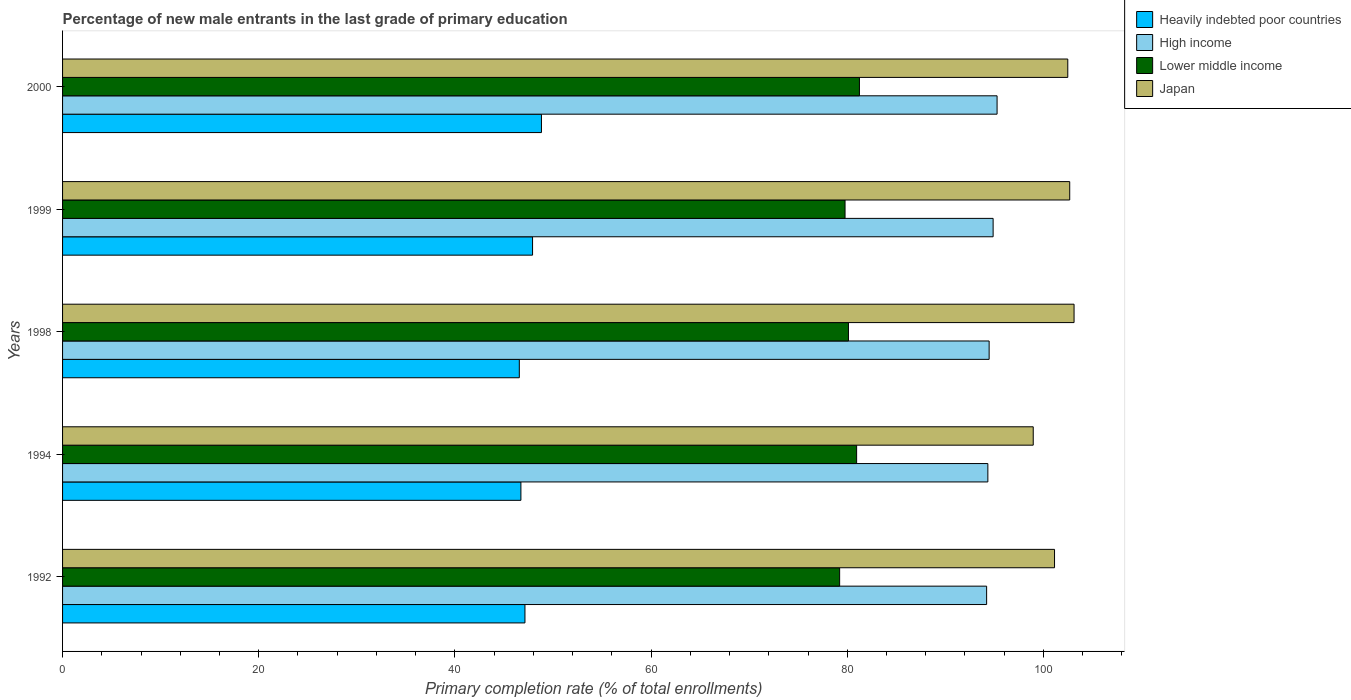How many groups of bars are there?
Offer a very short reply. 5. Are the number of bars per tick equal to the number of legend labels?
Your answer should be compact. Yes. Are the number of bars on each tick of the Y-axis equal?
Your answer should be compact. Yes. How many bars are there on the 3rd tick from the top?
Give a very brief answer. 4. What is the label of the 4th group of bars from the top?
Ensure brevity in your answer.  1994. What is the percentage of new male entrants in Lower middle income in 1998?
Your answer should be very brief. 80.12. Across all years, what is the maximum percentage of new male entrants in Japan?
Your answer should be compact. 103.12. Across all years, what is the minimum percentage of new male entrants in Heavily indebted poor countries?
Your answer should be very brief. 46.57. In which year was the percentage of new male entrants in High income minimum?
Ensure brevity in your answer.  1992. What is the total percentage of new male entrants in Lower middle income in the graph?
Keep it short and to the point. 401.32. What is the difference between the percentage of new male entrants in Japan in 1998 and that in 1999?
Provide a short and direct response. 0.44. What is the difference between the percentage of new male entrants in Lower middle income in 1994 and the percentage of new male entrants in Heavily indebted poor countries in 2000?
Provide a short and direct response. 32.13. What is the average percentage of new male entrants in Heavily indebted poor countries per year?
Keep it short and to the point. 47.43. In the year 1994, what is the difference between the percentage of new male entrants in Lower middle income and percentage of new male entrants in High income?
Make the answer very short. -13.38. What is the ratio of the percentage of new male entrants in High income in 1992 to that in 1999?
Give a very brief answer. 0.99. Is the percentage of new male entrants in Japan in 1994 less than that in 1999?
Offer a very short reply. Yes. Is the difference between the percentage of new male entrants in Lower middle income in 1992 and 1999 greater than the difference between the percentage of new male entrants in High income in 1992 and 1999?
Give a very brief answer. Yes. What is the difference between the highest and the second highest percentage of new male entrants in High income?
Your answer should be very brief. 0.4. What is the difference between the highest and the lowest percentage of new male entrants in Heavily indebted poor countries?
Give a very brief answer. 2.26. In how many years, is the percentage of new male entrants in High income greater than the average percentage of new male entrants in High income taken over all years?
Provide a succinct answer. 2. Is the sum of the percentage of new male entrants in Lower middle income in 1992 and 1998 greater than the maximum percentage of new male entrants in Heavily indebted poor countries across all years?
Offer a terse response. Yes. What does the 2nd bar from the bottom in 1998 represents?
Offer a terse response. High income. Is it the case that in every year, the sum of the percentage of new male entrants in Heavily indebted poor countries and percentage of new male entrants in Japan is greater than the percentage of new male entrants in Lower middle income?
Your answer should be very brief. Yes. Are all the bars in the graph horizontal?
Make the answer very short. Yes. What is the difference between two consecutive major ticks on the X-axis?
Offer a very short reply. 20. What is the title of the graph?
Give a very brief answer. Percentage of new male entrants in the last grade of primary education. Does "Belgium" appear as one of the legend labels in the graph?
Your response must be concise. No. What is the label or title of the X-axis?
Your response must be concise. Primary completion rate (% of total enrollments). What is the Primary completion rate (% of total enrollments) in Heavily indebted poor countries in 1992?
Offer a very short reply. 47.14. What is the Primary completion rate (% of total enrollments) of High income in 1992?
Offer a very short reply. 94.21. What is the Primary completion rate (% of total enrollments) in Lower middle income in 1992?
Your response must be concise. 79.22. What is the Primary completion rate (% of total enrollments) of Japan in 1992?
Your answer should be very brief. 101.13. What is the Primary completion rate (% of total enrollments) in Heavily indebted poor countries in 1994?
Your response must be concise. 46.73. What is the Primary completion rate (% of total enrollments) of High income in 1994?
Keep it short and to the point. 94.33. What is the Primary completion rate (% of total enrollments) of Lower middle income in 1994?
Your answer should be very brief. 80.96. What is the Primary completion rate (% of total enrollments) of Japan in 1994?
Give a very brief answer. 98.96. What is the Primary completion rate (% of total enrollments) in Heavily indebted poor countries in 1998?
Keep it short and to the point. 46.57. What is the Primary completion rate (% of total enrollments) of High income in 1998?
Give a very brief answer. 94.47. What is the Primary completion rate (% of total enrollments) in Lower middle income in 1998?
Make the answer very short. 80.12. What is the Primary completion rate (% of total enrollments) of Japan in 1998?
Your answer should be very brief. 103.12. What is the Primary completion rate (% of total enrollments) in Heavily indebted poor countries in 1999?
Make the answer very short. 47.92. What is the Primary completion rate (% of total enrollments) in High income in 1999?
Provide a short and direct response. 94.87. What is the Primary completion rate (% of total enrollments) of Lower middle income in 1999?
Ensure brevity in your answer.  79.77. What is the Primary completion rate (% of total enrollments) of Japan in 1999?
Your response must be concise. 102.68. What is the Primary completion rate (% of total enrollments) in Heavily indebted poor countries in 2000?
Offer a very short reply. 48.82. What is the Primary completion rate (% of total enrollments) of High income in 2000?
Offer a terse response. 95.27. What is the Primary completion rate (% of total enrollments) in Lower middle income in 2000?
Keep it short and to the point. 81.24. What is the Primary completion rate (% of total enrollments) in Japan in 2000?
Your answer should be very brief. 102.48. Across all years, what is the maximum Primary completion rate (% of total enrollments) of Heavily indebted poor countries?
Your answer should be very brief. 48.82. Across all years, what is the maximum Primary completion rate (% of total enrollments) of High income?
Your answer should be very brief. 95.27. Across all years, what is the maximum Primary completion rate (% of total enrollments) of Lower middle income?
Offer a very short reply. 81.24. Across all years, what is the maximum Primary completion rate (% of total enrollments) of Japan?
Ensure brevity in your answer.  103.12. Across all years, what is the minimum Primary completion rate (% of total enrollments) in Heavily indebted poor countries?
Your response must be concise. 46.57. Across all years, what is the minimum Primary completion rate (% of total enrollments) in High income?
Give a very brief answer. 94.21. Across all years, what is the minimum Primary completion rate (% of total enrollments) of Lower middle income?
Keep it short and to the point. 79.22. Across all years, what is the minimum Primary completion rate (% of total enrollments) of Japan?
Ensure brevity in your answer.  98.96. What is the total Primary completion rate (% of total enrollments) of Heavily indebted poor countries in the graph?
Provide a succinct answer. 237.17. What is the total Primary completion rate (% of total enrollments) of High income in the graph?
Keep it short and to the point. 473.15. What is the total Primary completion rate (% of total enrollments) of Lower middle income in the graph?
Give a very brief answer. 401.32. What is the total Primary completion rate (% of total enrollments) of Japan in the graph?
Give a very brief answer. 508.38. What is the difference between the Primary completion rate (% of total enrollments) of Heavily indebted poor countries in 1992 and that in 1994?
Give a very brief answer. 0.41. What is the difference between the Primary completion rate (% of total enrollments) in High income in 1992 and that in 1994?
Provide a succinct answer. -0.13. What is the difference between the Primary completion rate (% of total enrollments) of Lower middle income in 1992 and that in 1994?
Give a very brief answer. -1.73. What is the difference between the Primary completion rate (% of total enrollments) of Japan in 1992 and that in 1994?
Provide a short and direct response. 2.17. What is the difference between the Primary completion rate (% of total enrollments) in Heavily indebted poor countries in 1992 and that in 1998?
Offer a terse response. 0.58. What is the difference between the Primary completion rate (% of total enrollments) in High income in 1992 and that in 1998?
Keep it short and to the point. -0.26. What is the difference between the Primary completion rate (% of total enrollments) in Lower middle income in 1992 and that in 1998?
Your answer should be very brief. -0.9. What is the difference between the Primary completion rate (% of total enrollments) in Japan in 1992 and that in 1998?
Your answer should be compact. -1.99. What is the difference between the Primary completion rate (% of total enrollments) in Heavily indebted poor countries in 1992 and that in 1999?
Make the answer very short. -0.78. What is the difference between the Primary completion rate (% of total enrollments) of High income in 1992 and that in 1999?
Give a very brief answer. -0.66. What is the difference between the Primary completion rate (% of total enrollments) of Lower middle income in 1992 and that in 1999?
Offer a terse response. -0.55. What is the difference between the Primary completion rate (% of total enrollments) of Japan in 1992 and that in 1999?
Keep it short and to the point. -1.55. What is the difference between the Primary completion rate (% of total enrollments) of Heavily indebted poor countries in 1992 and that in 2000?
Ensure brevity in your answer.  -1.68. What is the difference between the Primary completion rate (% of total enrollments) in High income in 1992 and that in 2000?
Offer a very short reply. -1.07. What is the difference between the Primary completion rate (% of total enrollments) of Lower middle income in 1992 and that in 2000?
Ensure brevity in your answer.  -2.02. What is the difference between the Primary completion rate (% of total enrollments) of Japan in 1992 and that in 2000?
Keep it short and to the point. -1.35. What is the difference between the Primary completion rate (% of total enrollments) of Heavily indebted poor countries in 1994 and that in 1998?
Offer a very short reply. 0.16. What is the difference between the Primary completion rate (% of total enrollments) in High income in 1994 and that in 1998?
Make the answer very short. -0.13. What is the difference between the Primary completion rate (% of total enrollments) in Lower middle income in 1994 and that in 1998?
Your answer should be compact. 0.83. What is the difference between the Primary completion rate (% of total enrollments) in Japan in 1994 and that in 1998?
Provide a short and direct response. -4.16. What is the difference between the Primary completion rate (% of total enrollments) in Heavily indebted poor countries in 1994 and that in 1999?
Keep it short and to the point. -1.19. What is the difference between the Primary completion rate (% of total enrollments) of High income in 1994 and that in 1999?
Give a very brief answer. -0.54. What is the difference between the Primary completion rate (% of total enrollments) of Lower middle income in 1994 and that in 1999?
Your answer should be very brief. 1.18. What is the difference between the Primary completion rate (% of total enrollments) of Japan in 1994 and that in 1999?
Your answer should be very brief. -3.72. What is the difference between the Primary completion rate (% of total enrollments) in Heavily indebted poor countries in 1994 and that in 2000?
Keep it short and to the point. -2.09. What is the difference between the Primary completion rate (% of total enrollments) in High income in 1994 and that in 2000?
Make the answer very short. -0.94. What is the difference between the Primary completion rate (% of total enrollments) of Lower middle income in 1994 and that in 2000?
Provide a succinct answer. -0.29. What is the difference between the Primary completion rate (% of total enrollments) of Japan in 1994 and that in 2000?
Provide a succinct answer. -3.52. What is the difference between the Primary completion rate (% of total enrollments) in Heavily indebted poor countries in 1998 and that in 1999?
Provide a short and direct response. -1.35. What is the difference between the Primary completion rate (% of total enrollments) of High income in 1998 and that in 1999?
Provide a succinct answer. -0.41. What is the difference between the Primary completion rate (% of total enrollments) of Lower middle income in 1998 and that in 1999?
Provide a succinct answer. 0.35. What is the difference between the Primary completion rate (% of total enrollments) in Japan in 1998 and that in 1999?
Provide a succinct answer. 0.44. What is the difference between the Primary completion rate (% of total enrollments) of Heavily indebted poor countries in 1998 and that in 2000?
Ensure brevity in your answer.  -2.26. What is the difference between the Primary completion rate (% of total enrollments) in High income in 1998 and that in 2000?
Make the answer very short. -0.81. What is the difference between the Primary completion rate (% of total enrollments) in Lower middle income in 1998 and that in 2000?
Provide a succinct answer. -1.12. What is the difference between the Primary completion rate (% of total enrollments) of Japan in 1998 and that in 2000?
Your answer should be very brief. 0.64. What is the difference between the Primary completion rate (% of total enrollments) of Heavily indebted poor countries in 1999 and that in 2000?
Offer a terse response. -0.91. What is the difference between the Primary completion rate (% of total enrollments) in High income in 1999 and that in 2000?
Your answer should be very brief. -0.4. What is the difference between the Primary completion rate (% of total enrollments) of Lower middle income in 1999 and that in 2000?
Offer a very short reply. -1.47. What is the difference between the Primary completion rate (% of total enrollments) of Japan in 1999 and that in 2000?
Your response must be concise. 0.2. What is the difference between the Primary completion rate (% of total enrollments) of Heavily indebted poor countries in 1992 and the Primary completion rate (% of total enrollments) of High income in 1994?
Give a very brief answer. -47.19. What is the difference between the Primary completion rate (% of total enrollments) in Heavily indebted poor countries in 1992 and the Primary completion rate (% of total enrollments) in Lower middle income in 1994?
Your response must be concise. -33.81. What is the difference between the Primary completion rate (% of total enrollments) of Heavily indebted poor countries in 1992 and the Primary completion rate (% of total enrollments) of Japan in 1994?
Provide a succinct answer. -51.82. What is the difference between the Primary completion rate (% of total enrollments) of High income in 1992 and the Primary completion rate (% of total enrollments) of Lower middle income in 1994?
Offer a very short reply. 13.25. What is the difference between the Primary completion rate (% of total enrollments) in High income in 1992 and the Primary completion rate (% of total enrollments) in Japan in 1994?
Your response must be concise. -4.75. What is the difference between the Primary completion rate (% of total enrollments) of Lower middle income in 1992 and the Primary completion rate (% of total enrollments) of Japan in 1994?
Ensure brevity in your answer.  -19.74. What is the difference between the Primary completion rate (% of total enrollments) in Heavily indebted poor countries in 1992 and the Primary completion rate (% of total enrollments) in High income in 1998?
Make the answer very short. -47.32. What is the difference between the Primary completion rate (% of total enrollments) in Heavily indebted poor countries in 1992 and the Primary completion rate (% of total enrollments) in Lower middle income in 1998?
Provide a succinct answer. -32.98. What is the difference between the Primary completion rate (% of total enrollments) in Heavily indebted poor countries in 1992 and the Primary completion rate (% of total enrollments) in Japan in 1998?
Offer a very short reply. -55.98. What is the difference between the Primary completion rate (% of total enrollments) of High income in 1992 and the Primary completion rate (% of total enrollments) of Lower middle income in 1998?
Offer a terse response. 14.09. What is the difference between the Primary completion rate (% of total enrollments) of High income in 1992 and the Primary completion rate (% of total enrollments) of Japan in 1998?
Make the answer very short. -8.91. What is the difference between the Primary completion rate (% of total enrollments) in Lower middle income in 1992 and the Primary completion rate (% of total enrollments) in Japan in 1998?
Give a very brief answer. -23.9. What is the difference between the Primary completion rate (% of total enrollments) in Heavily indebted poor countries in 1992 and the Primary completion rate (% of total enrollments) in High income in 1999?
Give a very brief answer. -47.73. What is the difference between the Primary completion rate (% of total enrollments) in Heavily indebted poor countries in 1992 and the Primary completion rate (% of total enrollments) in Lower middle income in 1999?
Your answer should be compact. -32.63. What is the difference between the Primary completion rate (% of total enrollments) in Heavily indebted poor countries in 1992 and the Primary completion rate (% of total enrollments) in Japan in 1999?
Your answer should be compact. -55.54. What is the difference between the Primary completion rate (% of total enrollments) in High income in 1992 and the Primary completion rate (% of total enrollments) in Lower middle income in 1999?
Offer a very short reply. 14.43. What is the difference between the Primary completion rate (% of total enrollments) of High income in 1992 and the Primary completion rate (% of total enrollments) of Japan in 1999?
Your answer should be compact. -8.47. What is the difference between the Primary completion rate (% of total enrollments) of Lower middle income in 1992 and the Primary completion rate (% of total enrollments) of Japan in 1999?
Give a very brief answer. -23.46. What is the difference between the Primary completion rate (% of total enrollments) in Heavily indebted poor countries in 1992 and the Primary completion rate (% of total enrollments) in High income in 2000?
Your response must be concise. -48.13. What is the difference between the Primary completion rate (% of total enrollments) in Heavily indebted poor countries in 1992 and the Primary completion rate (% of total enrollments) in Lower middle income in 2000?
Offer a terse response. -34.1. What is the difference between the Primary completion rate (% of total enrollments) in Heavily indebted poor countries in 1992 and the Primary completion rate (% of total enrollments) in Japan in 2000?
Provide a succinct answer. -55.34. What is the difference between the Primary completion rate (% of total enrollments) in High income in 1992 and the Primary completion rate (% of total enrollments) in Lower middle income in 2000?
Provide a short and direct response. 12.97. What is the difference between the Primary completion rate (% of total enrollments) of High income in 1992 and the Primary completion rate (% of total enrollments) of Japan in 2000?
Offer a terse response. -8.27. What is the difference between the Primary completion rate (% of total enrollments) of Lower middle income in 1992 and the Primary completion rate (% of total enrollments) of Japan in 2000?
Your answer should be compact. -23.26. What is the difference between the Primary completion rate (% of total enrollments) in Heavily indebted poor countries in 1994 and the Primary completion rate (% of total enrollments) in High income in 1998?
Make the answer very short. -47.74. What is the difference between the Primary completion rate (% of total enrollments) in Heavily indebted poor countries in 1994 and the Primary completion rate (% of total enrollments) in Lower middle income in 1998?
Make the answer very short. -33.39. What is the difference between the Primary completion rate (% of total enrollments) of Heavily indebted poor countries in 1994 and the Primary completion rate (% of total enrollments) of Japan in 1998?
Keep it short and to the point. -56.39. What is the difference between the Primary completion rate (% of total enrollments) of High income in 1994 and the Primary completion rate (% of total enrollments) of Lower middle income in 1998?
Ensure brevity in your answer.  14.21. What is the difference between the Primary completion rate (% of total enrollments) of High income in 1994 and the Primary completion rate (% of total enrollments) of Japan in 1998?
Your answer should be compact. -8.79. What is the difference between the Primary completion rate (% of total enrollments) of Lower middle income in 1994 and the Primary completion rate (% of total enrollments) of Japan in 1998?
Keep it short and to the point. -22.17. What is the difference between the Primary completion rate (% of total enrollments) of Heavily indebted poor countries in 1994 and the Primary completion rate (% of total enrollments) of High income in 1999?
Ensure brevity in your answer.  -48.14. What is the difference between the Primary completion rate (% of total enrollments) in Heavily indebted poor countries in 1994 and the Primary completion rate (% of total enrollments) in Lower middle income in 1999?
Make the answer very short. -33.05. What is the difference between the Primary completion rate (% of total enrollments) of Heavily indebted poor countries in 1994 and the Primary completion rate (% of total enrollments) of Japan in 1999?
Your response must be concise. -55.95. What is the difference between the Primary completion rate (% of total enrollments) of High income in 1994 and the Primary completion rate (% of total enrollments) of Lower middle income in 1999?
Make the answer very short. 14.56. What is the difference between the Primary completion rate (% of total enrollments) of High income in 1994 and the Primary completion rate (% of total enrollments) of Japan in 1999?
Your response must be concise. -8.35. What is the difference between the Primary completion rate (% of total enrollments) in Lower middle income in 1994 and the Primary completion rate (% of total enrollments) in Japan in 1999?
Give a very brief answer. -21.72. What is the difference between the Primary completion rate (% of total enrollments) in Heavily indebted poor countries in 1994 and the Primary completion rate (% of total enrollments) in High income in 2000?
Your response must be concise. -48.55. What is the difference between the Primary completion rate (% of total enrollments) of Heavily indebted poor countries in 1994 and the Primary completion rate (% of total enrollments) of Lower middle income in 2000?
Keep it short and to the point. -34.51. What is the difference between the Primary completion rate (% of total enrollments) of Heavily indebted poor countries in 1994 and the Primary completion rate (% of total enrollments) of Japan in 2000?
Ensure brevity in your answer.  -55.75. What is the difference between the Primary completion rate (% of total enrollments) in High income in 1994 and the Primary completion rate (% of total enrollments) in Lower middle income in 2000?
Provide a short and direct response. 13.09. What is the difference between the Primary completion rate (% of total enrollments) in High income in 1994 and the Primary completion rate (% of total enrollments) in Japan in 2000?
Offer a very short reply. -8.15. What is the difference between the Primary completion rate (% of total enrollments) of Lower middle income in 1994 and the Primary completion rate (% of total enrollments) of Japan in 2000?
Ensure brevity in your answer.  -21.53. What is the difference between the Primary completion rate (% of total enrollments) in Heavily indebted poor countries in 1998 and the Primary completion rate (% of total enrollments) in High income in 1999?
Keep it short and to the point. -48.31. What is the difference between the Primary completion rate (% of total enrollments) of Heavily indebted poor countries in 1998 and the Primary completion rate (% of total enrollments) of Lower middle income in 1999?
Your answer should be compact. -33.21. What is the difference between the Primary completion rate (% of total enrollments) of Heavily indebted poor countries in 1998 and the Primary completion rate (% of total enrollments) of Japan in 1999?
Give a very brief answer. -56.11. What is the difference between the Primary completion rate (% of total enrollments) of High income in 1998 and the Primary completion rate (% of total enrollments) of Lower middle income in 1999?
Your answer should be very brief. 14.69. What is the difference between the Primary completion rate (% of total enrollments) of High income in 1998 and the Primary completion rate (% of total enrollments) of Japan in 1999?
Ensure brevity in your answer.  -8.21. What is the difference between the Primary completion rate (% of total enrollments) in Lower middle income in 1998 and the Primary completion rate (% of total enrollments) in Japan in 1999?
Your response must be concise. -22.56. What is the difference between the Primary completion rate (% of total enrollments) in Heavily indebted poor countries in 1998 and the Primary completion rate (% of total enrollments) in High income in 2000?
Your answer should be compact. -48.71. What is the difference between the Primary completion rate (% of total enrollments) in Heavily indebted poor countries in 1998 and the Primary completion rate (% of total enrollments) in Lower middle income in 2000?
Make the answer very short. -34.68. What is the difference between the Primary completion rate (% of total enrollments) in Heavily indebted poor countries in 1998 and the Primary completion rate (% of total enrollments) in Japan in 2000?
Your response must be concise. -55.92. What is the difference between the Primary completion rate (% of total enrollments) in High income in 1998 and the Primary completion rate (% of total enrollments) in Lower middle income in 2000?
Make the answer very short. 13.22. What is the difference between the Primary completion rate (% of total enrollments) of High income in 1998 and the Primary completion rate (% of total enrollments) of Japan in 2000?
Make the answer very short. -8.02. What is the difference between the Primary completion rate (% of total enrollments) in Lower middle income in 1998 and the Primary completion rate (% of total enrollments) in Japan in 2000?
Keep it short and to the point. -22.36. What is the difference between the Primary completion rate (% of total enrollments) in Heavily indebted poor countries in 1999 and the Primary completion rate (% of total enrollments) in High income in 2000?
Your answer should be compact. -47.36. What is the difference between the Primary completion rate (% of total enrollments) of Heavily indebted poor countries in 1999 and the Primary completion rate (% of total enrollments) of Lower middle income in 2000?
Your answer should be very brief. -33.33. What is the difference between the Primary completion rate (% of total enrollments) of Heavily indebted poor countries in 1999 and the Primary completion rate (% of total enrollments) of Japan in 2000?
Your response must be concise. -54.57. What is the difference between the Primary completion rate (% of total enrollments) of High income in 1999 and the Primary completion rate (% of total enrollments) of Lower middle income in 2000?
Offer a terse response. 13.63. What is the difference between the Primary completion rate (% of total enrollments) of High income in 1999 and the Primary completion rate (% of total enrollments) of Japan in 2000?
Give a very brief answer. -7.61. What is the difference between the Primary completion rate (% of total enrollments) in Lower middle income in 1999 and the Primary completion rate (% of total enrollments) in Japan in 2000?
Your answer should be compact. -22.71. What is the average Primary completion rate (% of total enrollments) of Heavily indebted poor countries per year?
Offer a very short reply. 47.44. What is the average Primary completion rate (% of total enrollments) in High income per year?
Make the answer very short. 94.63. What is the average Primary completion rate (% of total enrollments) in Lower middle income per year?
Give a very brief answer. 80.26. What is the average Primary completion rate (% of total enrollments) in Japan per year?
Offer a very short reply. 101.68. In the year 1992, what is the difference between the Primary completion rate (% of total enrollments) in Heavily indebted poor countries and Primary completion rate (% of total enrollments) in High income?
Your answer should be very brief. -47.07. In the year 1992, what is the difference between the Primary completion rate (% of total enrollments) in Heavily indebted poor countries and Primary completion rate (% of total enrollments) in Lower middle income?
Your answer should be very brief. -32.08. In the year 1992, what is the difference between the Primary completion rate (% of total enrollments) of Heavily indebted poor countries and Primary completion rate (% of total enrollments) of Japan?
Offer a terse response. -53.99. In the year 1992, what is the difference between the Primary completion rate (% of total enrollments) in High income and Primary completion rate (% of total enrollments) in Lower middle income?
Provide a short and direct response. 14.98. In the year 1992, what is the difference between the Primary completion rate (% of total enrollments) of High income and Primary completion rate (% of total enrollments) of Japan?
Your answer should be compact. -6.92. In the year 1992, what is the difference between the Primary completion rate (% of total enrollments) in Lower middle income and Primary completion rate (% of total enrollments) in Japan?
Ensure brevity in your answer.  -21.91. In the year 1994, what is the difference between the Primary completion rate (% of total enrollments) of Heavily indebted poor countries and Primary completion rate (% of total enrollments) of High income?
Keep it short and to the point. -47.6. In the year 1994, what is the difference between the Primary completion rate (% of total enrollments) in Heavily indebted poor countries and Primary completion rate (% of total enrollments) in Lower middle income?
Offer a very short reply. -34.23. In the year 1994, what is the difference between the Primary completion rate (% of total enrollments) of Heavily indebted poor countries and Primary completion rate (% of total enrollments) of Japan?
Your answer should be compact. -52.23. In the year 1994, what is the difference between the Primary completion rate (% of total enrollments) in High income and Primary completion rate (% of total enrollments) in Lower middle income?
Ensure brevity in your answer.  13.38. In the year 1994, what is the difference between the Primary completion rate (% of total enrollments) in High income and Primary completion rate (% of total enrollments) in Japan?
Keep it short and to the point. -4.63. In the year 1994, what is the difference between the Primary completion rate (% of total enrollments) in Lower middle income and Primary completion rate (% of total enrollments) in Japan?
Your response must be concise. -18.01. In the year 1998, what is the difference between the Primary completion rate (% of total enrollments) of Heavily indebted poor countries and Primary completion rate (% of total enrollments) of High income?
Provide a short and direct response. -47.9. In the year 1998, what is the difference between the Primary completion rate (% of total enrollments) of Heavily indebted poor countries and Primary completion rate (% of total enrollments) of Lower middle income?
Your answer should be compact. -33.56. In the year 1998, what is the difference between the Primary completion rate (% of total enrollments) in Heavily indebted poor countries and Primary completion rate (% of total enrollments) in Japan?
Offer a terse response. -56.56. In the year 1998, what is the difference between the Primary completion rate (% of total enrollments) of High income and Primary completion rate (% of total enrollments) of Lower middle income?
Your answer should be very brief. 14.34. In the year 1998, what is the difference between the Primary completion rate (% of total enrollments) of High income and Primary completion rate (% of total enrollments) of Japan?
Your response must be concise. -8.66. In the year 1998, what is the difference between the Primary completion rate (% of total enrollments) of Lower middle income and Primary completion rate (% of total enrollments) of Japan?
Your answer should be very brief. -23. In the year 1999, what is the difference between the Primary completion rate (% of total enrollments) in Heavily indebted poor countries and Primary completion rate (% of total enrollments) in High income?
Make the answer very short. -46.95. In the year 1999, what is the difference between the Primary completion rate (% of total enrollments) of Heavily indebted poor countries and Primary completion rate (% of total enrollments) of Lower middle income?
Ensure brevity in your answer.  -31.86. In the year 1999, what is the difference between the Primary completion rate (% of total enrollments) in Heavily indebted poor countries and Primary completion rate (% of total enrollments) in Japan?
Make the answer very short. -54.76. In the year 1999, what is the difference between the Primary completion rate (% of total enrollments) in High income and Primary completion rate (% of total enrollments) in Lower middle income?
Your response must be concise. 15.1. In the year 1999, what is the difference between the Primary completion rate (% of total enrollments) in High income and Primary completion rate (% of total enrollments) in Japan?
Your answer should be very brief. -7.81. In the year 1999, what is the difference between the Primary completion rate (% of total enrollments) in Lower middle income and Primary completion rate (% of total enrollments) in Japan?
Your response must be concise. -22.91. In the year 2000, what is the difference between the Primary completion rate (% of total enrollments) in Heavily indebted poor countries and Primary completion rate (% of total enrollments) in High income?
Keep it short and to the point. -46.45. In the year 2000, what is the difference between the Primary completion rate (% of total enrollments) in Heavily indebted poor countries and Primary completion rate (% of total enrollments) in Lower middle income?
Your response must be concise. -32.42. In the year 2000, what is the difference between the Primary completion rate (% of total enrollments) in Heavily indebted poor countries and Primary completion rate (% of total enrollments) in Japan?
Your answer should be compact. -53.66. In the year 2000, what is the difference between the Primary completion rate (% of total enrollments) of High income and Primary completion rate (% of total enrollments) of Lower middle income?
Keep it short and to the point. 14.03. In the year 2000, what is the difference between the Primary completion rate (% of total enrollments) of High income and Primary completion rate (% of total enrollments) of Japan?
Make the answer very short. -7.21. In the year 2000, what is the difference between the Primary completion rate (% of total enrollments) of Lower middle income and Primary completion rate (% of total enrollments) of Japan?
Ensure brevity in your answer.  -21.24. What is the ratio of the Primary completion rate (% of total enrollments) of Heavily indebted poor countries in 1992 to that in 1994?
Offer a very short reply. 1.01. What is the ratio of the Primary completion rate (% of total enrollments) of Lower middle income in 1992 to that in 1994?
Provide a short and direct response. 0.98. What is the ratio of the Primary completion rate (% of total enrollments) in Japan in 1992 to that in 1994?
Give a very brief answer. 1.02. What is the ratio of the Primary completion rate (% of total enrollments) in Heavily indebted poor countries in 1992 to that in 1998?
Offer a very short reply. 1.01. What is the ratio of the Primary completion rate (% of total enrollments) of High income in 1992 to that in 1998?
Ensure brevity in your answer.  1. What is the ratio of the Primary completion rate (% of total enrollments) of Japan in 1992 to that in 1998?
Ensure brevity in your answer.  0.98. What is the ratio of the Primary completion rate (% of total enrollments) of Heavily indebted poor countries in 1992 to that in 1999?
Make the answer very short. 0.98. What is the ratio of the Primary completion rate (% of total enrollments) of Lower middle income in 1992 to that in 1999?
Offer a terse response. 0.99. What is the ratio of the Primary completion rate (% of total enrollments) of Japan in 1992 to that in 1999?
Provide a succinct answer. 0.98. What is the ratio of the Primary completion rate (% of total enrollments) in Heavily indebted poor countries in 1992 to that in 2000?
Provide a short and direct response. 0.97. What is the ratio of the Primary completion rate (% of total enrollments) of High income in 1992 to that in 2000?
Make the answer very short. 0.99. What is the ratio of the Primary completion rate (% of total enrollments) in Lower middle income in 1992 to that in 2000?
Make the answer very short. 0.98. What is the ratio of the Primary completion rate (% of total enrollments) in High income in 1994 to that in 1998?
Offer a terse response. 1. What is the ratio of the Primary completion rate (% of total enrollments) of Lower middle income in 1994 to that in 1998?
Provide a succinct answer. 1.01. What is the ratio of the Primary completion rate (% of total enrollments) of Japan in 1994 to that in 1998?
Make the answer very short. 0.96. What is the ratio of the Primary completion rate (% of total enrollments) in Heavily indebted poor countries in 1994 to that in 1999?
Give a very brief answer. 0.98. What is the ratio of the Primary completion rate (% of total enrollments) in Lower middle income in 1994 to that in 1999?
Provide a succinct answer. 1.01. What is the ratio of the Primary completion rate (% of total enrollments) in Japan in 1994 to that in 1999?
Offer a terse response. 0.96. What is the ratio of the Primary completion rate (% of total enrollments) in Heavily indebted poor countries in 1994 to that in 2000?
Your response must be concise. 0.96. What is the ratio of the Primary completion rate (% of total enrollments) in Lower middle income in 1994 to that in 2000?
Offer a very short reply. 1. What is the ratio of the Primary completion rate (% of total enrollments) in Japan in 1994 to that in 2000?
Your response must be concise. 0.97. What is the ratio of the Primary completion rate (% of total enrollments) in Heavily indebted poor countries in 1998 to that in 1999?
Ensure brevity in your answer.  0.97. What is the ratio of the Primary completion rate (% of total enrollments) of High income in 1998 to that in 1999?
Offer a very short reply. 1. What is the ratio of the Primary completion rate (% of total enrollments) of Japan in 1998 to that in 1999?
Provide a succinct answer. 1. What is the ratio of the Primary completion rate (% of total enrollments) of Heavily indebted poor countries in 1998 to that in 2000?
Ensure brevity in your answer.  0.95. What is the ratio of the Primary completion rate (% of total enrollments) of High income in 1998 to that in 2000?
Give a very brief answer. 0.99. What is the ratio of the Primary completion rate (% of total enrollments) of Lower middle income in 1998 to that in 2000?
Offer a very short reply. 0.99. What is the ratio of the Primary completion rate (% of total enrollments) in Japan in 1998 to that in 2000?
Provide a short and direct response. 1.01. What is the ratio of the Primary completion rate (% of total enrollments) of Heavily indebted poor countries in 1999 to that in 2000?
Keep it short and to the point. 0.98. What is the ratio of the Primary completion rate (% of total enrollments) of High income in 1999 to that in 2000?
Offer a terse response. 1. What is the ratio of the Primary completion rate (% of total enrollments) in Lower middle income in 1999 to that in 2000?
Provide a short and direct response. 0.98. What is the difference between the highest and the second highest Primary completion rate (% of total enrollments) in Heavily indebted poor countries?
Make the answer very short. 0.91. What is the difference between the highest and the second highest Primary completion rate (% of total enrollments) in High income?
Provide a short and direct response. 0.4. What is the difference between the highest and the second highest Primary completion rate (% of total enrollments) in Lower middle income?
Your response must be concise. 0.29. What is the difference between the highest and the second highest Primary completion rate (% of total enrollments) in Japan?
Provide a short and direct response. 0.44. What is the difference between the highest and the lowest Primary completion rate (% of total enrollments) in Heavily indebted poor countries?
Make the answer very short. 2.26. What is the difference between the highest and the lowest Primary completion rate (% of total enrollments) in High income?
Your answer should be very brief. 1.07. What is the difference between the highest and the lowest Primary completion rate (% of total enrollments) in Lower middle income?
Provide a succinct answer. 2.02. What is the difference between the highest and the lowest Primary completion rate (% of total enrollments) of Japan?
Your answer should be very brief. 4.16. 